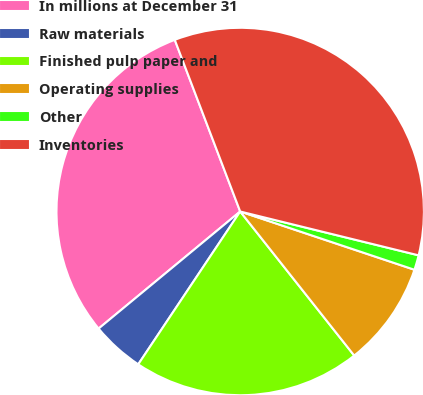Convert chart to OTSL. <chart><loc_0><loc_0><loc_500><loc_500><pie_chart><fcel>In millions at December 31<fcel>Raw materials<fcel>Finished pulp paper and<fcel>Operating supplies<fcel>Other<fcel>Inventories<nl><fcel>30.2%<fcel>4.64%<fcel>20.02%<fcel>9.21%<fcel>1.3%<fcel>34.63%<nl></chart> 